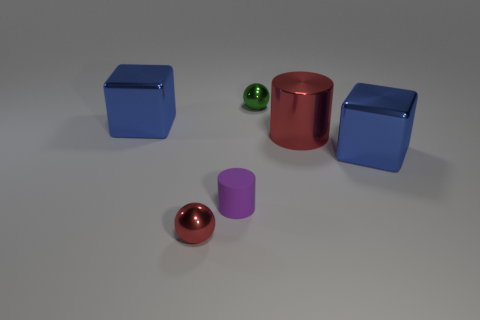Is the number of shiny objects in front of the small red sphere greater than the number of purple objects?
Ensure brevity in your answer.  No. Does the metallic cylinder have the same size as the purple object?
Keep it short and to the point. No. The other small thing that is the same material as the small red object is what color?
Your answer should be compact. Green. What shape is the small thing that is the same color as the big cylinder?
Give a very brief answer. Sphere. Is the number of red spheres behind the metallic cylinder the same as the number of spheres that are on the left side of the small green metallic thing?
Give a very brief answer. No. There is a small shiny object that is behind the big object left of the tiny green metallic ball; what is its shape?
Your answer should be compact. Sphere. What is the material of the large red thing that is the same shape as the tiny purple matte thing?
Provide a succinct answer. Metal. There is another metallic ball that is the same size as the green ball; what is its color?
Offer a very short reply. Red. Are there the same number of tiny green spheres that are left of the purple rubber thing and big blue metal cubes?
Offer a terse response. No. There is a small thing behind the blue shiny object behind the shiny cylinder; what color is it?
Ensure brevity in your answer.  Green. 